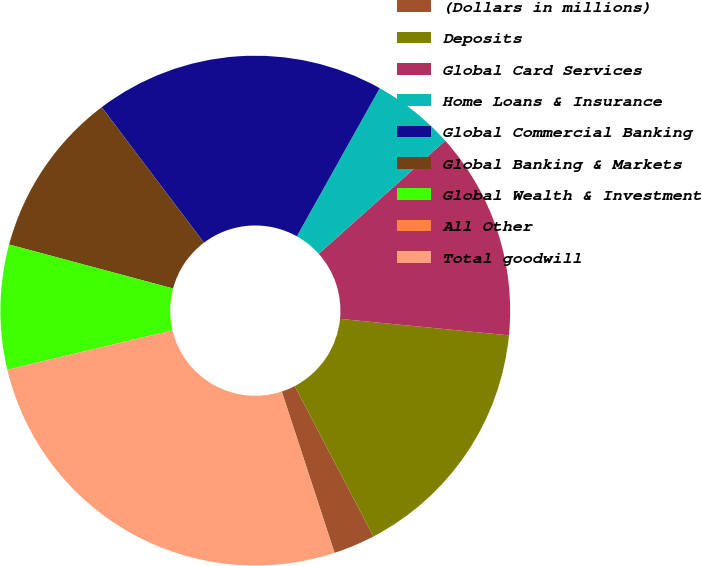Convert chart to OTSL. <chart><loc_0><loc_0><loc_500><loc_500><pie_chart><fcel>(Dollars in millions)<fcel>Deposits<fcel>Global Card Services<fcel>Home Loans & Insurance<fcel>Global Commercial Banking<fcel>Global Banking & Markets<fcel>Global Wealth & Investment<fcel>All Other<fcel>Total goodwill<nl><fcel>2.64%<fcel>15.78%<fcel>13.16%<fcel>5.27%<fcel>18.41%<fcel>10.53%<fcel>7.9%<fcel>0.01%<fcel>26.3%<nl></chart> 